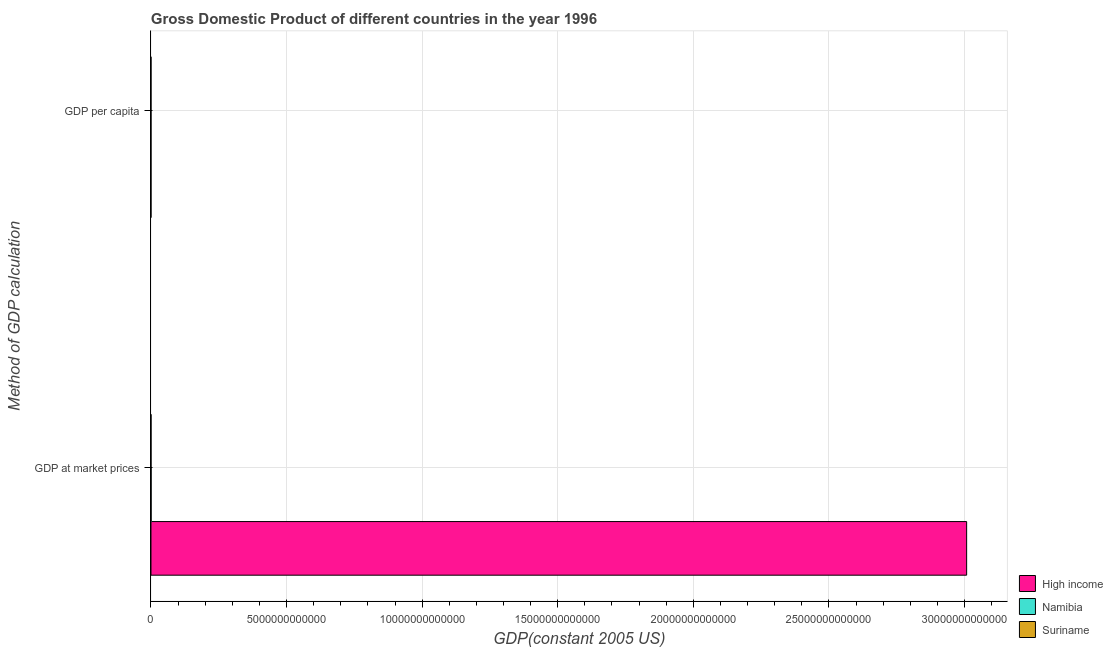How many groups of bars are there?
Your answer should be compact. 2. How many bars are there on the 2nd tick from the top?
Your answer should be very brief. 3. How many bars are there on the 2nd tick from the bottom?
Ensure brevity in your answer.  3. What is the label of the 2nd group of bars from the top?
Your answer should be compact. GDP at market prices. What is the gdp per capita in High income?
Ensure brevity in your answer.  2.40e+04. Across all countries, what is the maximum gdp per capita?
Keep it short and to the point. 2.40e+04. Across all countries, what is the minimum gdp per capita?
Give a very brief answer. 2814.19. In which country was the gdp at market prices maximum?
Make the answer very short. High income. In which country was the gdp at market prices minimum?
Offer a terse response. Suriname. What is the total gdp per capita in the graph?
Keep it short and to the point. 2.97e+04. What is the difference between the gdp at market prices in Namibia and that in Suriname?
Give a very brief answer. 3.68e+09. What is the difference between the gdp per capita in High income and the gdp at market prices in Namibia?
Provide a succinct answer. -4.96e+09. What is the average gdp at market prices per country?
Ensure brevity in your answer.  1.00e+13. What is the difference between the gdp per capita and gdp at market prices in Suriname?
Ensure brevity in your answer.  -1.28e+09. What is the ratio of the gdp per capita in Namibia to that in High income?
Offer a very short reply. 0.12. Is the gdp per capita in Namibia less than that in High income?
Ensure brevity in your answer.  Yes. What does the 2nd bar from the top in GDP per capita represents?
Offer a terse response. Namibia. What does the 3rd bar from the bottom in GDP at market prices represents?
Make the answer very short. Suriname. How many bars are there?
Keep it short and to the point. 6. Are all the bars in the graph horizontal?
Your answer should be compact. Yes. What is the difference between two consecutive major ticks on the X-axis?
Provide a short and direct response. 5.00e+12. How are the legend labels stacked?
Your response must be concise. Vertical. What is the title of the graph?
Make the answer very short. Gross Domestic Product of different countries in the year 1996. Does "Fiji" appear as one of the legend labels in the graph?
Your answer should be compact. No. What is the label or title of the X-axis?
Keep it short and to the point. GDP(constant 2005 US). What is the label or title of the Y-axis?
Give a very brief answer. Method of GDP calculation. What is the GDP(constant 2005 US) in High income in GDP at market prices?
Provide a succinct answer. 3.01e+13. What is the GDP(constant 2005 US) in Namibia in GDP at market prices?
Keep it short and to the point. 4.96e+09. What is the GDP(constant 2005 US) of Suriname in GDP at market prices?
Give a very brief answer. 1.28e+09. What is the GDP(constant 2005 US) in High income in GDP per capita?
Keep it short and to the point. 2.40e+04. What is the GDP(constant 2005 US) of Namibia in GDP per capita?
Provide a succinct answer. 2906.32. What is the GDP(constant 2005 US) of Suriname in GDP per capita?
Your answer should be very brief. 2814.19. Across all Method of GDP calculation, what is the maximum GDP(constant 2005 US) of High income?
Give a very brief answer. 3.01e+13. Across all Method of GDP calculation, what is the maximum GDP(constant 2005 US) in Namibia?
Ensure brevity in your answer.  4.96e+09. Across all Method of GDP calculation, what is the maximum GDP(constant 2005 US) of Suriname?
Offer a terse response. 1.28e+09. Across all Method of GDP calculation, what is the minimum GDP(constant 2005 US) in High income?
Provide a succinct answer. 2.40e+04. Across all Method of GDP calculation, what is the minimum GDP(constant 2005 US) of Namibia?
Ensure brevity in your answer.  2906.32. Across all Method of GDP calculation, what is the minimum GDP(constant 2005 US) in Suriname?
Provide a short and direct response. 2814.19. What is the total GDP(constant 2005 US) of High income in the graph?
Offer a terse response. 3.01e+13. What is the total GDP(constant 2005 US) of Namibia in the graph?
Your answer should be compact. 4.96e+09. What is the total GDP(constant 2005 US) in Suriname in the graph?
Your answer should be compact. 1.28e+09. What is the difference between the GDP(constant 2005 US) in High income in GDP at market prices and that in GDP per capita?
Provide a succinct answer. 3.01e+13. What is the difference between the GDP(constant 2005 US) of Namibia in GDP at market prices and that in GDP per capita?
Your answer should be very brief. 4.96e+09. What is the difference between the GDP(constant 2005 US) of Suriname in GDP at market prices and that in GDP per capita?
Offer a terse response. 1.28e+09. What is the difference between the GDP(constant 2005 US) of High income in GDP at market prices and the GDP(constant 2005 US) of Namibia in GDP per capita?
Offer a terse response. 3.01e+13. What is the difference between the GDP(constant 2005 US) in High income in GDP at market prices and the GDP(constant 2005 US) in Suriname in GDP per capita?
Your response must be concise. 3.01e+13. What is the difference between the GDP(constant 2005 US) in Namibia in GDP at market prices and the GDP(constant 2005 US) in Suriname in GDP per capita?
Ensure brevity in your answer.  4.96e+09. What is the average GDP(constant 2005 US) in High income per Method of GDP calculation?
Keep it short and to the point. 1.50e+13. What is the average GDP(constant 2005 US) of Namibia per Method of GDP calculation?
Provide a short and direct response. 2.48e+09. What is the average GDP(constant 2005 US) of Suriname per Method of GDP calculation?
Provide a short and direct response. 6.38e+08. What is the difference between the GDP(constant 2005 US) in High income and GDP(constant 2005 US) in Namibia in GDP at market prices?
Your answer should be compact. 3.01e+13. What is the difference between the GDP(constant 2005 US) in High income and GDP(constant 2005 US) in Suriname in GDP at market prices?
Your answer should be very brief. 3.01e+13. What is the difference between the GDP(constant 2005 US) in Namibia and GDP(constant 2005 US) in Suriname in GDP at market prices?
Provide a succinct answer. 3.68e+09. What is the difference between the GDP(constant 2005 US) of High income and GDP(constant 2005 US) of Namibia in GDP per capita?
Keep it short and to the point. 2.11e+04. What is the difference between the GDP(constant 2005 US) in High income and GDP(constant 2005 US) in Suriname in GDP per capita?
Provide a short and direct response. 2.12e+04. What is the difference between the GDP(constant 2005 US) in Namibia and GDP(constant 2005 US) in Suriname in GDP per capita?
Ensure brevity in your answer.  92.14. What is the ratio of the GDP(constant 2005 US) of High income in GDP at market prices to that in GDP per capita?
Your answer should be compact. 1.25e+09. What is the ratio of the GDP(constant 2005 US) of Namibia in GDP at market prices to that in GDP per capita?
Provide a succinct answer. 1.71e+06. What is the ratio of the GDP(constant 2005 US) of Suriname in GDP at market prices to that in GDP per capita?
Give a very brief answer. 4.54e+05. What is the difference between the highest and the second highest GDP(constant 2005 US) of High income?
Offer a very short reply. 3.01e+13. What is the difference between the highest and the second highest GDP(constant 2005 US) in Namibia?
Make the answer very short. 4.96e+09. What is the difference between the highest and the second highest GDP(constant 2005 US) of Suriname?
Make the answer very short. 1.28e+09. What is the difference between the highest and the lowest GDP(constant 2005 US) in High income?
Keep it short and to the point. 3.01e+13. What is the difference between the highest and the lowest GDP(constant 2005 US) in Namibia?
Offer a very short reply. 4.96e+09. What is the difference between the highest and the lowest GDP(constant 2005 US) in Suriname?
Provide a short and direct response. 1.28e+09. 